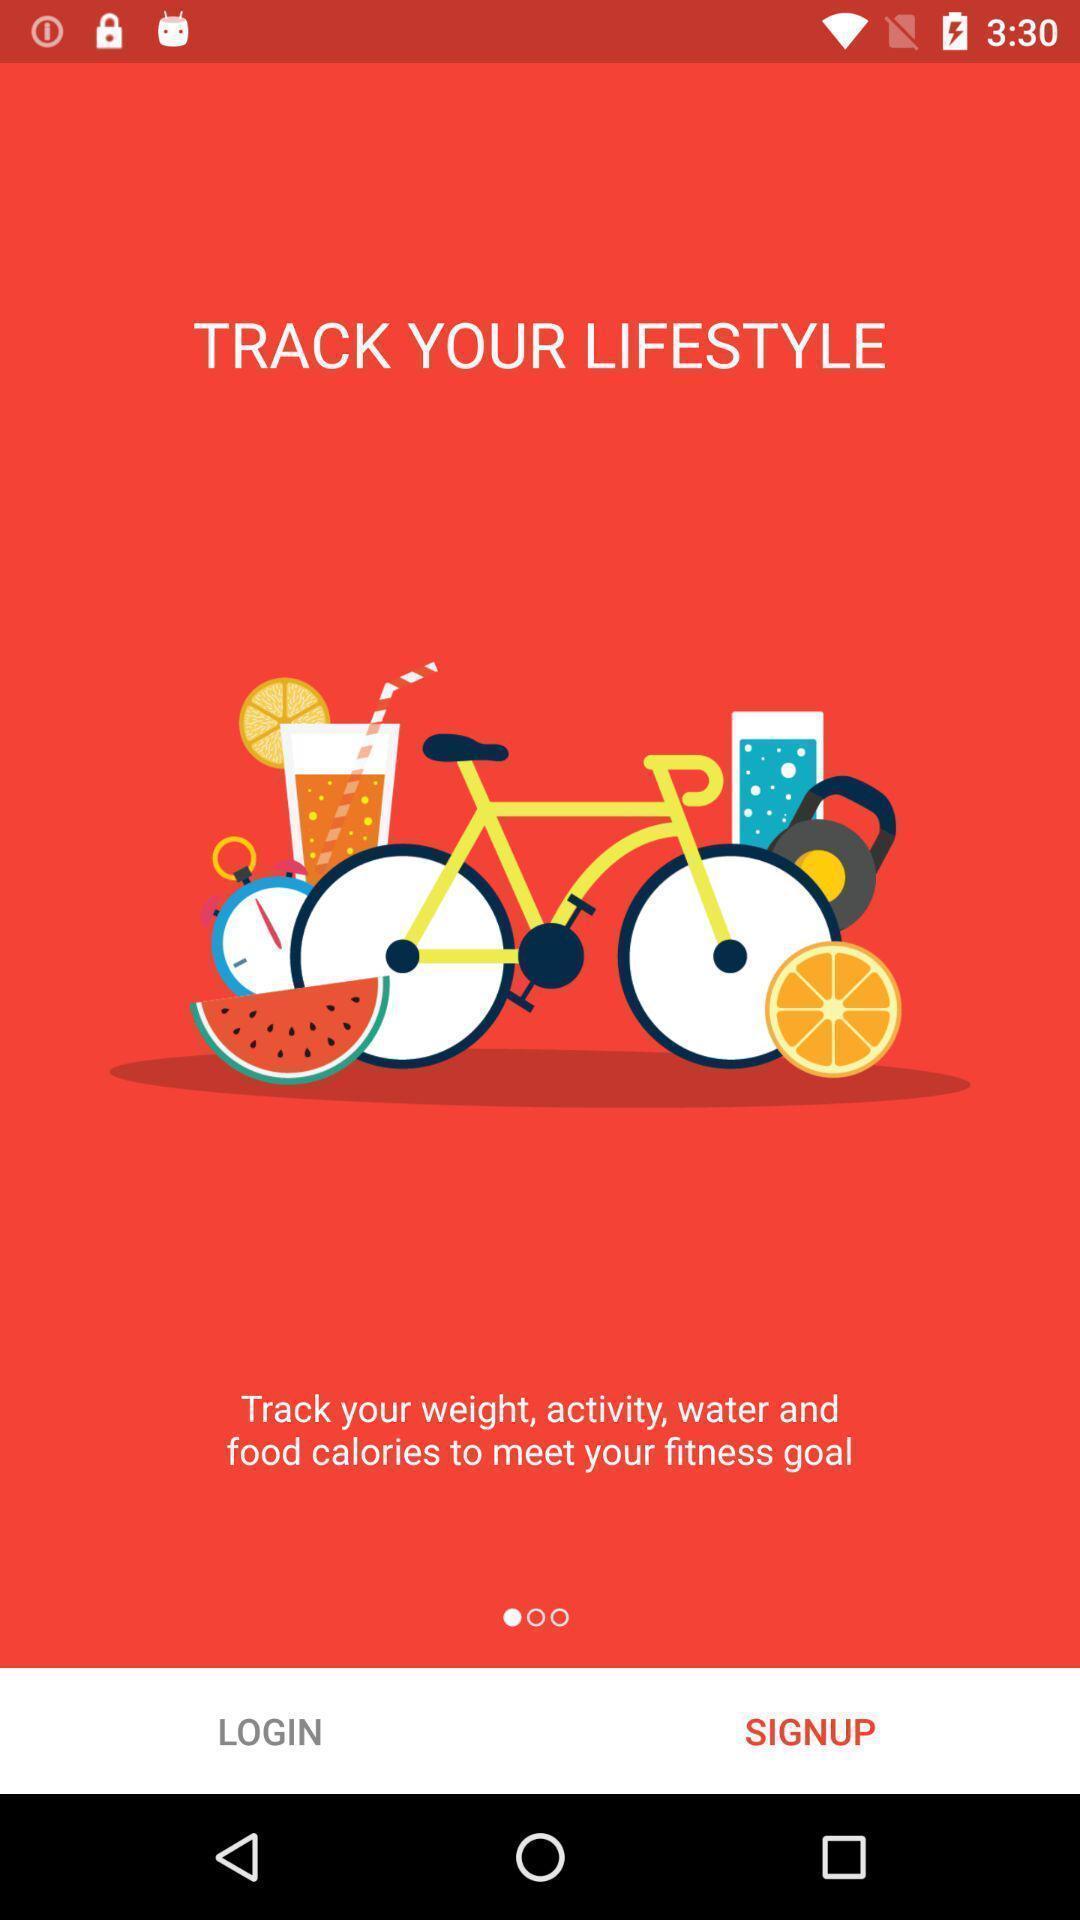Explain the elements present in this screenshot. Welcome page with options for a health monitoring app. 